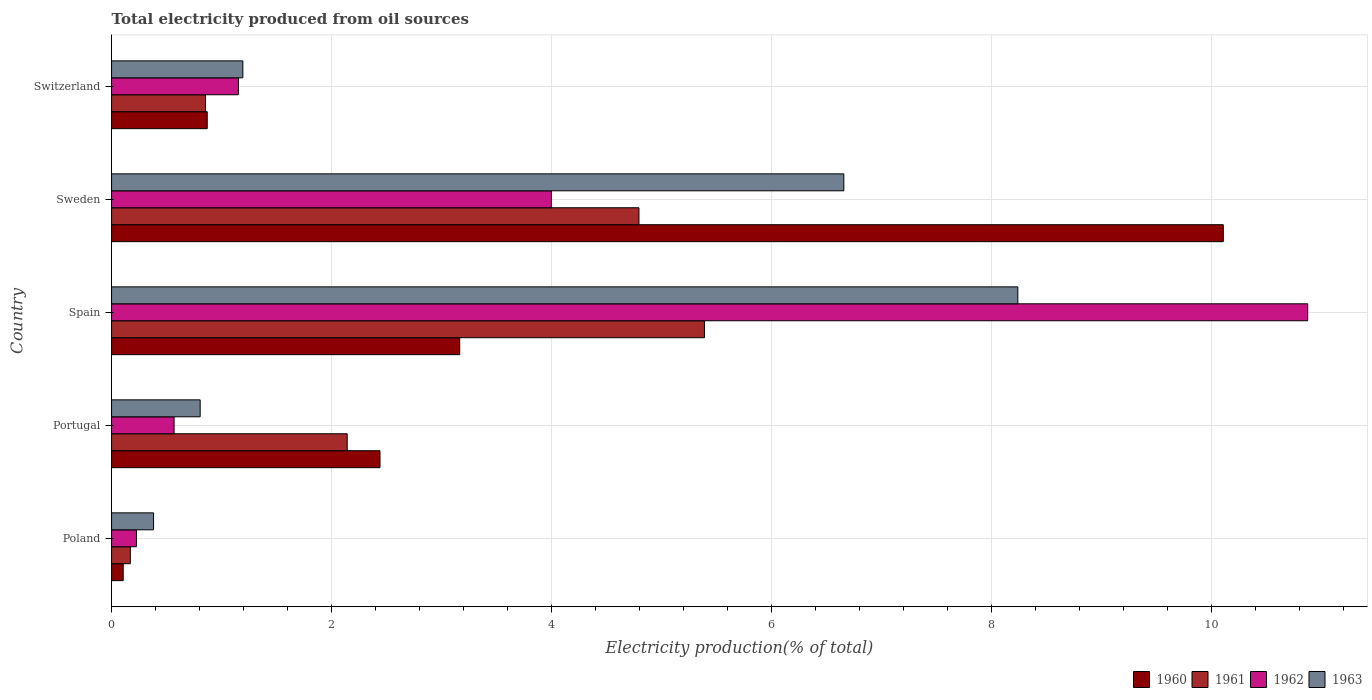How many different coloured bars are there?
Give a very brief answer. 4. Are the number of bars per tick equal to the number of legend labels?
Keep it short and to the point. Yes. Are the number of bars on each tick of the Y-axis equal?
Provide a short and direct response. Yes. How many bars are there on the 2nd tick from the top?
Offer a terse response. 4. How many bars are there on the 1st tick from the bottom?
Your response must be concise. 4. What is the label of the 3rd group of bars from the top?
Provide a succinct answer. Spain. What is the total electricity produced in 1962 in Spain?
Provide a succinct answer. 10.87. Across all countries, what is the maximum total electricity produced in 1962?
Ensure brevity in your answer.  10.87. Across all countries, what is the minimum total electricity produced in 1961?
Your answer should be compact. 0.17. In which country was the total electricity produced in 1963 minimum?
Your answer should be compact. Poland. What is the total total electricity produced in 1960 in the graph?
Make the answer very short. 16.68. What is the difference between the total electricity produced in 1960 in Sweden and that in Switzerland?
Give a very brief answer. 9.23. What is the difference between the total electricity produced in 1961 in Switzerland and the total electricity produced in 1962 in Spain?
Ensure brevity in your answer.  -10.02. What is the average total electricity produced in 1961 per country?
Offer a terse response. 2.67. What is the difference between the total electricity produced in 1963 and total electricity produced in 1961 in Spain?
Ensure brevity in your answer.  2.85. What is the ratio of the total electricity produced in 1963 in Portugal to that in Spain?
Make the answer very short. 0.1. Is the total electricity produced in 1960 in Poland less than that in Sweden?
Offer a very short reply. Yes. Is the difference between the total electricity produced in 1963 in Spain and Sweden greater than the difference between the total electricity produced in 1961 in Spain and Sweden?
Your answer should be compact. Yes. What is the difference between the highest and the second highest total electricity produced in 1962?
Offer a very short reply. 6.87. What is the difference between the highest and the lowest total electricity produced in 1961?
Keep it short and to the point. 5.22. In how many countries, is the total electricity produced in 1960 greater than the average total electricity produced in 1960 taken over all countries?
Provide a short and direct response. 1. Is the sum of the total electricity produced in 1963 in Sweden and Switzerland greater than the maximum total electricity produced in 1960 across all countries?
Your answer should be compact. No. Is it the case that in every country, the sum of the total electricity produced in 1963 and total electricity produced in 1962 is greater than the sum of total electricity produced in 1961 and total electricity produced in 1960?
Your answer should be very brief. No. What does the 2nd bar from the top in Spain represents?
Keep it short and to the point. 1962. What does the 1st bar from the bottom in Switzerland represents?
Provide a succinct answer. 1960. How many bars are there?
Keep it short and to the point. 20. Are all the bars in the graph horizontal?
Your response must be concise. Yes. What is the difference between two consecutive major ticks on the X-axis?
Your response must be concise. 2. Does the graph contain grids?
Provide a short and direct response. Yes. How many legend labels are there?
Offer a terse response. 4. How are the legend labels stacked?
Make the answer very short. Horizontal. What is the title of the graph?
Provide a succinct answer. Total electricity produced from oil sources. What is the Electricity production(% of total) of 1960 in Poland?
Keep it short and to the point. 0.11. What is the Electricity production(% of total) of 1961 in Poland?
Give a very brief answer. 0.17. What is the Electricity production(% of total) in 1962 in Poland?
Your answer should be compact. 0.23. What is the Electricity production(% of total) in 1963 in Poland?
Give a very brief answer. 0.38. What is the Electricity production(% of total) of 1960 in Portugal?
Keep it short and to the point. 2.44. What is the Electricity production(% of total) in 1961 in Portugal?
Offer a terse response. 2.14. What is the Electricity production(% of total) of 1962 in Portugal?
Your answer should be very brief. 0.57. What is the Electricity production(% of total) of 1963 in Portugal?
Ensure brevity in your answer.  0.81. What is the Electricity production(% of total) in 1960 in Spain?
Give a very brief answer. 3.16. What is the Electricity production(% of total) of 1961 in Spain?
Make the answer very short. 5.39. What is the Electricity production(% of total) of 1962 in Spain?
Provide a succinct answer. 10.87. What is the Electricity production(% of total) in 1963 in Spain?
Your answer should be very brief. 8.24. What is the Electricity production(% of total) in 1960 in Sweden?
Your response must be concise. 10.1. What is the Electricity production(% of total) in 1961 in Sweden?
Ensure brevity in your answer.  4.79. What is the Electricity production(% of total) of 1962 in Sweden?
Offer a very short reply. 4. What is the Electricity production(% of total) of 1963 in Sweden?
Your response must be concise. 6.66. What is the Electricity production(% of total) of 1960 in Switzerland?
Make the answer very short. 0.87. What is the Electricity production(% of total) in 1961 in Switzerland?
Offer a very short reply. 0.85. What is the Electricity production(% of total) of 1962 in Switzerland?
Give a very brief answer. 1.15. What is the Electricity production(% of total) in 1963 in Switzerland?
Ensure brevity in your answer.  1.19. Across all countries, what is the maximum Electricity production(% of total) in 1960?
Keep it short and to the point. 10.1. Across all countries, what is the maximum Electricity production(% of total) of 1961?
Make the answer very short. 5.39. Across all countries, what is the maximum Electricity production(% of total) in 1962?
Your response must be concise. 10.87. Across all countries, what is the maximum Electricity production(% of total) of 1963?
Ensure brevity in your answer.  8.24. Across all countries, what is the minimum Electricity production(% of total) of 1960?
Your answer should be compact. 0.11. Across all countries, what is the minimum Electricity production(% of total) in 1961?
Ensure brevity in your answer.  0.17. Across all countries, what is the minimum Electricity production(% of total) in 1962?
Provide a short and direct response. 0.23. Across all countries, what is the minimum Electricity production(% of total) of 1963?
Your response must be concise. 0.38. What is the total Electricity production(% of total) in 1960 in the graph?
Provide a succinct answer. 16.68. What is the total Electricity production(% of total) of 1961 in the graph?
Your answer should be compact. 13.35. What is the total Electricity production(% of total) in 1962 in the graph?
Make the answer very short. 16.82. What is the total Electricity production(% of total) in 1963 in the graph?
Ensure brevity in your answer.  17.27. What is the difference between the Electricity production(% of total) of 1960 in Poland and that in Portugal?
Ensure brevity in your answer.  -2.33. What is the difference between the Electricity production(% of total) of 1961 in Poland and that in Portugal?
Provide a succinct answer. -1.97. What is the difference between the Electricity production(% of total) of 1962 in Poland and that in Portugal?
Offer a terse response. -0.34. What is the difference between the Electricity production(% of total) in 1963 in Poland and that in Portugal?
Your answer should be very brief. -0.42. What is the difference between the Electricity production(% of total) in 1960 in Poland and that in Spain?
Give a very brief answer. -3.06. What is the difference between the Electricity production(% of total) of 1961 in Poland and that in Spain?
Give a very brief answer. -5.22. What is the difference between the Electricity production(% of total) of 1962 in Poland and that in Spain?
Your answer should be very brief. -10.64. What is the difference between the Electricity production(% of total) in 1963 in Poland and that in Spain?
Provide a succinct answer. -7.85. What is the difference between the Electricity production(% of total) of 1960 in Poland and that in Sweden?
Your answer should be very brief. -10. What is the difference between the Electricity production(% of total) in 1961 in Poland and that in Sweden?
Ensure brevity in your answer.  -4.62. What is the difference between the Electricity production(% of total) of 1962 in Poland and that in Sweden?
Offer a terse response. -3.77. What is the difference between the Electricity production(% of total) in 1963 in Poland and that in Sweden?
Keep it short and to the point. -6.27. What is the difference between the Electricity production(% of total) in 1960 in Poland and that in Switzerland?
Your response must be concise. -0.76. What is the difference between the Electricity production(% of total) of 1961 in Poland and that in Switzerland?
Provide a short and direct response. -0.68. What is the difference between the Electricity production(% of total) of 1962 in Poland and that in Switzerland?
Your answer should be very brief. -0.93. What is the difference between the Electricity production(% of total) in 1963 in Poland and that in Switzerland?
Your answer should be very brief. -0.81. What is the difference between the Electricity production(% of total) in 1960 in Portugal and that in Spain?
Offer a very short reply. -0.72. What is the difference between the Electricity production(% of total) in 1961 in Portugal and that in Spain?
Your response must be concise. -3.25. What is the difference between the Electricity production(% of total) of 1962 in Portugal and that in Spain?
Ensure brevity in your answer.  -10.3. What is the difference between the Electricity production(% of total) in 1963 in Portugal and that in Spain?
Provide a short and direct response. -7.43. What is the difference between the Electricity production(% of total) in 1960 in Portugal and that in Sweden?
Offer a terse response. -7.66. What is the difference between the Electricity production(% of total) in 1961 in Portugal and that in Sweden?
Ensure brevity in your answer.  -2.65. What is the difference between the Electricity production(% of total) of 1962 in Portugal and that in Sweden?
Your response must be concise. -3.43. What is the difference between the Electricity production(% of total) in 1963 in Portugal and that in Sweden?
Your answer should be very brief. -5.85. What is the difference between the Electricity production(% of total) in 1960 in Portugal and that in Switzerland?
Offer a very short reply. 1.57. What is the difference between the Electricity production(% of total) of 1961 in Portugal and that in Switzerland?
Offer a terse response. 1.29. What is the difference between the Electricity production(% of total) of 1962 in Portugal and that in Switzerland?
Your answer should be very brief. -0.59. What is the difference between the Electricity production(% of total) of 1963 in Portugal and that in Switzerland?
Make the answer very short. -0.39. What is the difference between the Electricity production(% of total) of 1960 in Spain and that in Sweden?
Offer a terse response. -6.94. What is the difference between the Electricity production(% of total) of 1961 in Spain and that in Sweden?
Ensure brevity in your answer.  0.6. What is the difference between the Electricity production(% of total) in 1962 in Spain and that in Sweden?
Make the answer very short. 6.87. What is the difference between the Electricity production(% of total) in 1963 in Spain and that in Sweden?
Ensure brevity in your answer.  1.58. What is the difference between the Electricity production(% of total) of 1960 in Spain and that in Switzerland?
Ensure brevity in your answer.  2.29. What is the difference between the Electricity production(% of total) in 1961 in Spain and that in Switzerland?
Ensure brevity in your answer.  4.53. What is the difference between the Electricity production(% of total) of 1962 in Spain and that in Switzerland?
Make the answer very short. 9.72. What is the difference between the Electricity production(% of total) in 1963 in Spain and that in Switzerland?
Provide a short and direct response. 7.04. What is the difference between the Electricity production(% of total) in 1960 in Sweden and that in Switzerland?
Your response must be concise. 9.23. What is the difference between the Electricity production(% of total) of 1961 in Sweden and that in Switzerland?
Your response must be concise. 3.94. What is the difference between the Electricity production(% of total) in 1962 in Sweden and that in Switzerland?
Your response must be concise. 2.84. What is the difference between the Electricity production(% of total) of 1963 in Sweden and that in Switzerland?
Your response must be concise. 5.46. What is the difference between the Electricity production(% of total) in 1960 in Poland and the Electricity production(% of total) in 1961 in Portugal?
Give a very brief answer. -2.04. What is the difference between the Electricity production(% of total) in 1960 in Poland and the Electricity production(% of total) in 1962 in Portugal?
Offer a terse response. -0.46. What is the difference between the Electricity production(% of total) in 1960 in Poland and the Electricity production(% of total) in 1963 in Portugal?
Your answer should be very brief. -0.7. What is the difference between the Electricity production(% of total) in 1961 in Poland and the Electricity production(% of total) in 1962 in Portugal?
Give a very brief answer. -0.4. What is the difference between the Electricity production(% of total) in 1961 in Poland and the Electricity production(% of total) in 1963 in Portugal?
Keep it short and to the point. -0.63. What is the difference between the Electricity production(% of total) in 1962 in Poland and the Electricity production(% of total) in 1963 in Portugal?
Provide a short and direct response. -0.58. What is the difference between the Electricity production(% of total) of 1960 in Poland and the Electricity production(% of total) of 1961 in Spain?
Make the answer very short. -5.28. What is the difference between the Electricity production(% of total) of 1960 in Poland and the Electricity production(% of total) of 1962 in Spain?
Make the answer very short. -10.77. What is the difference between the Electricity production(% of total) in 1960 in Poland and the Electricity production(% of total) in 1963 in Spain?
Offer a very short reply. -8.13. What is the difference between the Electricity production(% of total) of 1961 in Poland and the Electricity production(% of total) of 1962 in Spain?
Your response must be concise. -10.7. What is the difference between the Electricity production(% of total) in 1961 in Poland and the Electricity production(% of total) in 1963 in Spain?
Offer a terse response. -8.07. What is the difference between the Electricity production(% of total) in 1962 in Poland and the Electricity production(% of total) in 1963 in Spain?
Your response must be concise. -8.01. What is the difference between the Electricity production(% of total) in 1960 in Poland and the Electricity production(% of total) in 1961 in Sweden?
Provide a succinct answer. -4.69. What is the difference between the Electricity production(% of total) in 1960 in Poland and the Electricity production(% of total) in 1962 in Sweden?
Provide a succinct answer. -3.89. What is the difference between the Electricity production(% of total) in 1960 in Poland and the Electricity production(% of total) in 1963 in Sweden?
Your response must be concise. -6.55. What is the difference between the Electricity production(% of total) in 1961 in Poland and the Electricity production(% of total) in 1962 in Sweden?
Ensure brevity in your answer.  -3.83. What is the difference between the Electricity production(% of total) of 1961 in Poland and the Electricity production(% of total) of 1963 in Sweden?
Your answer should be very brief. -6.48. What is the difference between the Electricity production(% of total) in 1962 in Poland and the Electricity production(% of total) in 1963 in Sweden?
Provide a succinct answer. -6.43. What is the difference between the Electricity production(% of total) of 1960 in Poland and the Electricity production(% of total) of 1961 in Switzerland?
Ensure brevity in your answer.  -0.75. What is the difference between the Electricity production(% of total) in 1960 in Poland and the Electricity production(% of total) in 1962 in Switzerland?
Your answer should be compact. -1.05. What is the difference between the Electricity production(% of total) of 1960 in Poland and the Electricity production(% of total) of 1963 in Switzerland?
Provide a succinct answer. -1.09. What is the difference between the Electricity production(% of total) in 1961 in Poland and the Electricity production(% of total) in 1962 in Switzerland?
Provide a succinct answer. -0.98. What is the difference between the Electricity production(% of total) in 1961 in Poland and the Electricity production(% of total) in 1963 in Switzerland?
Give a very brief answer. -1.02. What is the difference between the Electricity production(% of total) of 1962 in Poland and the Electricity production(% of total) of 1963 in Switzerland?
Offer a terse response. -0.97. What is the difference between the Electricity production(% of total) in 1960 in Portugal and the Electricity production(% of total) in 1961 in Spain?
Your answer should be compact. -2.95. What is the difference between the Electricity production(% of total) of 1960 in Portugal and the Electricity production(% of total) of 1962 in Spain?
Offer a very short reply. -8.43. What is the difference between the Electricity production(% of total) of 1960 in Portugal and the Electricity production(% of total) of 1963 in Spain?
Provide a succinct answer. -5.8. What is the difference between the Electricity production(% of total) in 1961 in Portugal and the Electricity production(% of total) in 1962 in Spain?
Your answer should be very brief. -8.73. What is the difference between the Electricity production(% of total) of 1961 in Portugal and the Electricity production(% of total) of 1963 in Spain?
Keep it short and to the point. -6.09. What is the difference between the Electricity production(% of total) of 1962 in Portugal and the Electricity production(% of total) of 1963 in Spain?
Ensure brevity in your answer.  -7.67. What is the difference between the Electricity production(% of total) in 1960 in Portugal and the Electricity production(% of total) in 1961 in Sweden?
Your response must be concise. -2.35. What is the difference between the Electricity production(% of total) of 1960 in Portugal and the Electricity production(% of total) of 1962 in Sweden?
Ensure brevity in your answer.  -1.56. What is the difference between the Electricity production(% of total) of 1960 in Portugal and the Electricity production(% of total) of 1963 in Sweden?
Provide a succinct answer. -4.22. What is the difference between the Electricity production(% of total) in 1961 in Portugal and the Electricity production(% of total) in 1962 in Sweden?
Provide a succinct answer. -1.86. What is the difference between the Electricity production(% of total) in 1961 in Portugal and the Electricity production(% of total) in 1963 in Sweden?
Provide a short and direct response. -4.51. What is the difference between the Electricity production(% of total) of 1962 in Portugal and the Electricity production(% of total) of 1963 in Sweden?
Your answer should be compact. -6.09. What is the difference between the Electricity production(% of total) of 1960 in Portugal and the Electricity production(% of total) of 1961 in Switzerland?
Give a very brief answer. 1.59. What is the difference between the Electricity production(% of total) of 1960 in Portugal and the Electricity production(% of total) of 1962 in Switzerland?
Offer a terse response. 1.29. What is the difference between the Electricity production(% of total) in 1960 in Portugal and the Electricity production(% of total) in 1963 in Switzerland?
Your answer should be compact. 1.25. What is the difference between the Electricity production(% of total) of 1961 in Portugal and the Electricity production(% of total) of 1962 in Switzerland?
Ensure brevity in your answer.  0.99. What is the difference between the Electricity production(% of total) in 1961 in Portugal and the Electricity production(% of total) in 1963 in Switzerland?
Your response must be concise. 0.95. What is the difference between the Electricity production(% of total) in 1962 in Portugal and the Electricity production(% of total) in 1963 in Switzerland?
Offer a very short reply. -0.63. What is the difference between the Electricity production(% of total) of 1960 in Spain and the Electricity production(% of total) of 1961 in Sweden?
Offer a terse response. -1.63. What is the difference between the Electricity production(% of total) of 1960 in Spain and the Electricity production(% of total) of 1962 in Sweden?
Give a very brief answer. -0.83. What is the difference between the Electricity production(% of total) in 1960 in Spain and the Electricity production(% of total) in 1963 in Sweden?
Your answer should be compact. -3.49. What is the difference between the Electricity production(% of total) in 1961 in Spain and the Electricity production(% of total) in 1962 in Sweden?
Ensure brevity in your answer.  1.39. What is the difference between the Electricity production(% of total) of 1961 in Spain and the Electricity production(% of total) of 1963 in Sweden?
Ensure brevity in your answer.  -1.27. What is the difference between the Electricity production(% of total) in 1962 in Spain and the Electricity production(% of total) in 1963 in Sweden?
Your answer should be compact. 4.22. What is the difference between the Electricity production(% of total) of 1960 in Spain and the Electricity production(% of total) of 1961 in Switzerland?
Make the answer very short. 2.31. What is the difference between the Electricity production(% of total) in 1960 in Spain and the Electricity production(% of total) in 1962 in Switzerland?
Your answer should be compact. 2.01. What is the difference between the Electricity production(% of total) in 1960 in Spain and the Electricity production(% of total) in 1963 in Switzerland?
Make the answer very short. 1.97. What is the difference between the Electricity production(% of total) in 1961 in Spain and the Electricity production(% of total) in 1962 in Switzerland?
Offer a very short reply. 4.24. What is the difference between the Electricity production(% of total) of 1961 in Spain and the Electricity production(% of total) of 1963 in Switzerland?
Offer a terse response. 4.2. What is the difference between the Electricity production(% of total) in 1962 in Spain and the Electricity production(% of total) in 1963 in Switzerland?
Ensure brevity in your answer.  9.68. What is the difference between the Electricity production(% of total) in 1960 in Sweden and the Electricity production(% of total) in 1961 in Switzerland?
Your response must be concise. 9.25. What is the difference between the Electricity production(% of total) in 1960 in Sweden and the Electricity production(% of total) in 1962 in Switzerland?
Your answer should be very brief. 8.95. What is the difference between the Electricity production(% of total) of 1960 in Sweden and the Electricity production(% of total) of 1963 in Switzerland?
Your response must be concise. 8.91. What is the difference between the Electricity production(% of total) of 1961 in Sweden and the Electricity production(% of total) of 1962 in Switzerland?
Provide a succinct answer. 3.64. What is the difference between the Electricity production(% of total) of 1961 in Sweden and the Electricity production(% of total) of 1963 in Switzerland?
Offer a terse response. 3.6. What is the difference between the Electricity production(% of total) in 1962 in Sweden and the Electricity production(% of total) in 1963 in Switzerland?
Ensure brevity in your answer.  2.8. What is the average Electricity production(% of total) in 1960 per country?
Ensure brevity in your answer.  3.34. What is the average Electricity production(% of total) in 1961 per country?
Provide a succinct answer. 2.67. What is the average Electricity production(% of total) of 1962 per country?
Your answer should be compact. 3.36. What is the average Electricity production(% of total) in 1963 per country?
Give a very brief answer. 3.45. What is the difference between the Electricity production(% of total) in 1960 and Electricity production(% of total) in 1961 in Poland?
Ensure brevity in your answer.  -0.06. What is the difference between the Electricity production(% of total) of 1960 and Electricity production(% of total) of 1962 in Poland?
Your response must be concise. -0.12. What is the difference between the Electricity production(% of total) of 1960 and Electricity production(% of total) of 1963 in Poland?
Make the answer very short. -0.28. What is the difference between the Electricity production(% of total) of 1961 and Electricity production(% of total) of 1962 in Poland?
Offer a very short reply. -0.06. What is the difference between the Electricity production(% of total) in 1961 and Electricity production(% of total) in 1963 in Poland?
Your answer should be very brief. -0.21. What is the difference between the Electricity production(% of total) of 1962 and Electricity production(% of total) of 1963 in Poland?
Provide a succinct answer. -0.16. What is the difference between the Electricity production(% of total) of 1960 and Electricity production(% of total) of 1961 in Portugal?
Give a very brief answer. 0.3. What is the difference between the Electricity production(% of total) in 1960 and Electricity production(% of total) in 1962 in Portugal?
Provide a short and direct response. 1.87. What is the difference between the Electricity production(% of total) in 1960 and Electricity production(% of total) in 1963 in Portugal?
Offer a terse response. 1.63. What is the difference between the Electricity production(% of total) of 1961 and Electricity production(% of total) of 1962 in Portugal?
Keep it short and to the point. 1.57. What is the difference between the Electricity production(% of total) of 1961 and Electricity production(% of total) of 1963 in Portugal?
Keep it short and to the point. 1.34. What is the difference between the Electricity production(% of total) in 1962 and Electricity production(% of total) in 1963 in Portugal?
Provide a succinct answer. -0.24. What is the difference between the Electricity production(% of total) in 1960 and Electricity production(% of total) in 1961 in Spain?
Offer a very short reply. -2.22. What is the difference between the Electricity production(% of total) in 1960 and Electricity production(% of total) in 1962 in Spain?
Provide a succinct answer. -7.71. What is the difference between the Electricity production(% of total) in 1960 and Electricity production(% of total) in 1963 in Spain?
Your answer should be very brief. -5.07. What is the difference between the Electricity production(% of total) of 1961 and Electricity production(% of total) of 1962 in Spain?
Ensure brevity in your answer.  -5.48. What is the difference between the Electricity production(% of total) in 1961 and Electricity production(% of total) in 1963 in Spain?
Your response must be concise. -2.85. What is the difference between the Electricity production(% of total) in 1962 and Electricity production(% of total) in 1963 in Spain?
Ensure brevity in your answer.  2.63. What is the difference between the Electricity production(% of total) of 1960 and Electricity production(% of total) of 1961 in Sweden?
Offer a very short reply. 5.31. What is the difference between the Electricity production(% of total) of 1960 and Electricity production(% of total) of 1962 in Sweden?
Offer a very short reply. 6.11. What is the difference between the Electricity production(% of total) of 1960 and Electricity production(% of total) of 1963 in Sweden?
Give a very brief answer. 3.45. What is the difference between the Electricity production(% of total) in 1961 and Electricity production(% of total) in 1962 in Sweden?
Give a very brief answer. 0.8. What is the difference between the Electricity production(% of total) of 1961 and Electricity production(% of total) of 1963 in Sweden?
Offer a terse response. -1.86. What is the difference between the Electricity production(% of total) in 1962 and Electricity production(% of total) in 1963 in Sweden?
Keep it short and to the point. -2.66. What is the difference between the Electricity production(% of total) of 1960 and Electricity production(% of total) of 1961 in Switzerland?
Your answer should be very brief. 0.02. What is the difference between the Electricity production(% of total) in 1960 and Electricity production(% of total) in 1962 in Switzerland?
Your answer should be very brief. -0.28. What is the difference between the Electricity production(% of total) in 1960 and Electricity production(% of total) in 1963 in Switzerland?
Keep it short and to the point. -0.32. What is the difference between the Electricity production(% of total) of 1961 and Electricity production(% of total) of 1962 in Switzerland?
Your answer should be very brief. -0.3. What is the difference between the Electricity production(% of total) of 1961 and Electricity production(% of total) of 1963 in Switzerland?
Ensure brevity in your answer.  -0.34. What is the difference between the Electricity production(% of total) of 1962 and Electricity production(% of total) of 1963 in Switzerland?
Your answer should be very brief. -0.04. What is the ratio of the Electricity production(% of total) of 1960 in Poland to that in Portugal?
Your answer should be compact. 0.04. What is the ratio of the Electricity production(% of total) in 1961 in Poland to that in Portugal?
Provide a short and direct response. 0.08. What is the ratio of the Electricity production(% of total) of 1962 in Poland to that in Portugal?
Provide a succinct answer. 0.4. What is the ratio of the Electricity production(% of total) of 1963 in Poland to that in Portugal?
Make the answer very short. 0.47. What is the ratio of the Electricity production(% of total) in 1960 in Poland to that in Spain?
Your response must be concise. 0.03. What is the ratio of the Electricity production(% of total) of 1961 in Poland to that in Spain?
Your answer should be compact. 0.03. What is the ratio of the Electricity production(% of total) of 1962 in Poland to that in Spain?
Ensure brevity in your answer.  0.02. What is the ratio of the Electricity production(% of total) in 1963 in Poland to that in Spain?
Your answer should be very brief. 0.05. What is the ratio of the Electricity production(% of total) of 1960 in Poland to that in Sweden?
Offer a terse response. 0.01. What is the ratio of the Electricity production(% of total) in 1961 in Poland to that in Sweden?
Keep it short and to the point. 0.04. What is the ratio of the Electricity production(% of total) in 1962 in Poland to that in Sweden?
Offer a terse response. 0.06. What is the ratio of the Electricity production(% of total) of 1963 in Poland to that in Sweden?
Your answer should be compact. 0.06. What is the ratio of the Electricity production(% of total) in 1960 in Poland to that in Switzerland?
Provide a succinct answer. 0.12. What is the ratio of the Electricity production(% of total) of 1961 in Poland to that in Switzerland?
Give a very brief answer. 0.2. What is the ratio of the Electricity production(% of total) of 1962 in Poland to that in Switzerland?
Make the answer very short. 0.2. What is the ratio of the Electricity production(% of total) in 1963 in Poland to that in Switzerland?
Make the answer very short. 0.32. What is the ratio of the Electricity production(% of total) of 1960 in Portugal to that in Spain?
Offer a terse response. 0.77. What is the ratio of the Electricity production(% of total) of 1961 in Portugal to that in Spain?
Your response must be concise. 0.4. What is the ratio of the Electricity production(% of total) of 1962 in Portugal to that in Spain?
Offer a very short reply. 0.05. What is the ratio of the Electricity production(% of total) of 1963 in Portugal to that in Spain?
Make the answer very short. 0.1. What is the ratio of the Electricity production(% of total) of 1960 in Portugal to that in Sweden?
Provide a short and direct response. 0.24. What is the ratio of the Electricity production(% of total) of 1961 in Portugal to that in Sweden?
Give a very brief answer. 0.45. What is the ratio of the Electricity production(% of total) in 1962 in Portugal to that in Sweden?
Keep it short and to the point. 0.14. What is the ratio of the Electricity production(% of total) of 1963 in Portugal to that in Sweden?
Your answer should be compact. 0.12. What is the ratio of the Electricity production(% of total) of 1960 in Portugal to that in Switzerland?
Ensure brevity in your answer.  2.81. What is the ratio of the Electricity production(% of total) of 1961 in Portugal to that in Switzerland?
Your response must be concise. 2.51. What is the ratio of the Electricity production(% of total) of 1962 in Portugal to that in Switzerland?
Keep it short and to the point. 0.49. What is the ratio of the Electricity production(% of total) of 1963 in Portugal to that in Switzerland?
Offer a terse response. 0.67. What is the ratio of the Electricity production(% of total) of 1960 in Spain to that in Sweden?
Ensure brevity in your answer.  0.31. What is the ratio of the Electricity production(% of total) of 1961 in Spain to that in Sweden?
Your response must be concise. 1.12. What is the ratio of the Electricity production(% of total) in 1962 in Spain to that in Sweden?
Make the answer very short. 2.72. What is the ratio of the Electricity production(% of total) of 1963 in Spain to that in Sweden?
Offer a very short reply. 1.24. What is the ratio of the Electricity production(% of total) in 1960 in Spain to that in Switzerland?
Make the answer very short. 3.64. What is the ratio of the Electricity production(% of total) in 1961 in Spain to that in Switzerland?
Provide a short and direct response. 6.31. What is the ratio of the Electricity production(% of total) in 1962 in Spain to that in Switzerland?
Make the answer very short. 9.43. What is the ratio of the Electricity production(% of total) in 1963 in Spain to that in Switzerland?
Keep it short and to the point. 6.9. What is the ratio of the Electricity production(% of total) in 1960 in Sweden to that in Switzerland?
Ensure brevity in your answer.  11.62. What is the ratio of the Electricity production(% of total) of 1961 in Sweden to that in Switzerland?
Give a very brief answer. 5.62. What is the ratio of the Electricity production(% of total) of 1962 in Sweden to that in Switzerland?
Keep it short and to the point. 3.47. What is the ratio of the Electricity production(% of total) of 1963 in Sweden to that in Switzerland?
Your response must be concise. 5.58. What is the difference between the highest and the second highest Electricity production(% of total) in 1960?
Provide a short and direct response. 6.94. What is the difference between the highest and the second highest Electricity production(% of total) in 1961?
Give a very brief answer. 0.6. What is the difference between the highest and the second highest Electricity production(% of total) of 1962?
Keep it short and to the point. 6.87. What is the difference between the highest and the second highest Electricity production(% of total) of 1963?
Provide a short and direct response. 1.58. What is the difference between the highest and the lowest Electricity production(% of total) of 1960?
Offer a very short reply. 10. What is the difference between the highest and the lowest Electricity production(% of total) of 1961?
Provide a short and direct response. 5.22. What is the difference between the highest and the lowest Electricity production(% of total) of 1962?
Keep it short and to the point. 10.64. What is the difference between the highest and the lowest Electricity production(% of total) of 1963?
Your answer should be very brief. 7.85. 